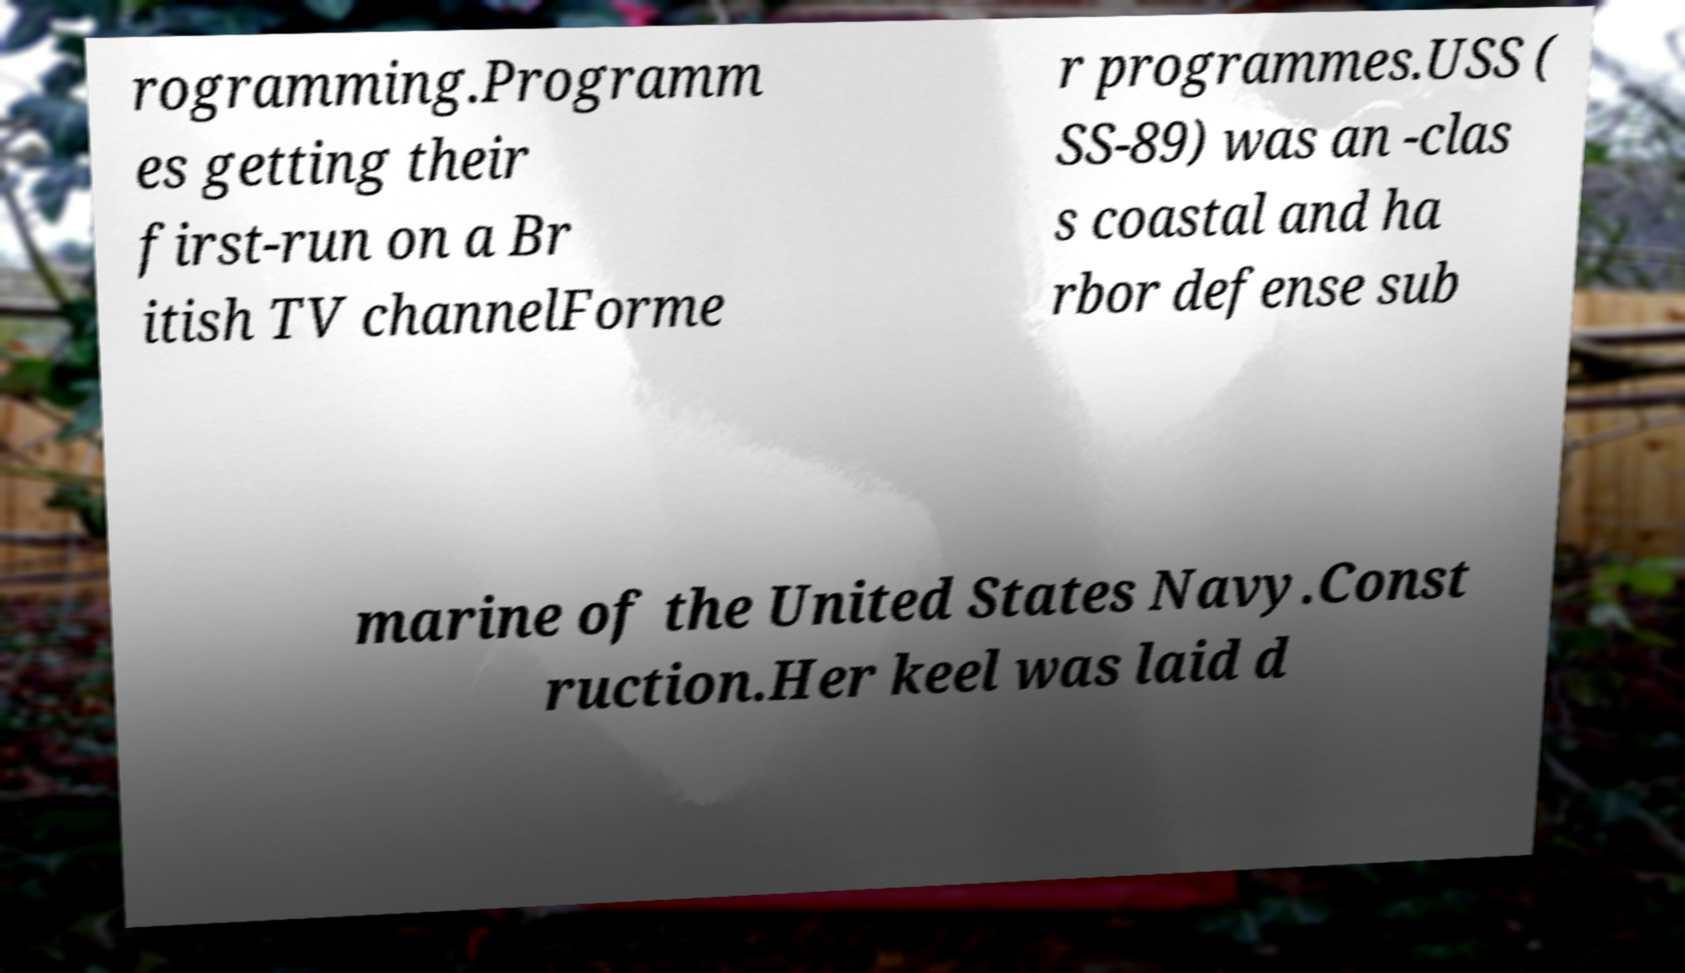Could you extract and type out the text from this image? rogramming.Programm es getting their first-run on a Br itish TV channelForme r programmes.USS ( SS-89) was an -clas s coastal and ha rbor defense sub marine of the United States Navy.Const ruction.Her keel was laid d 